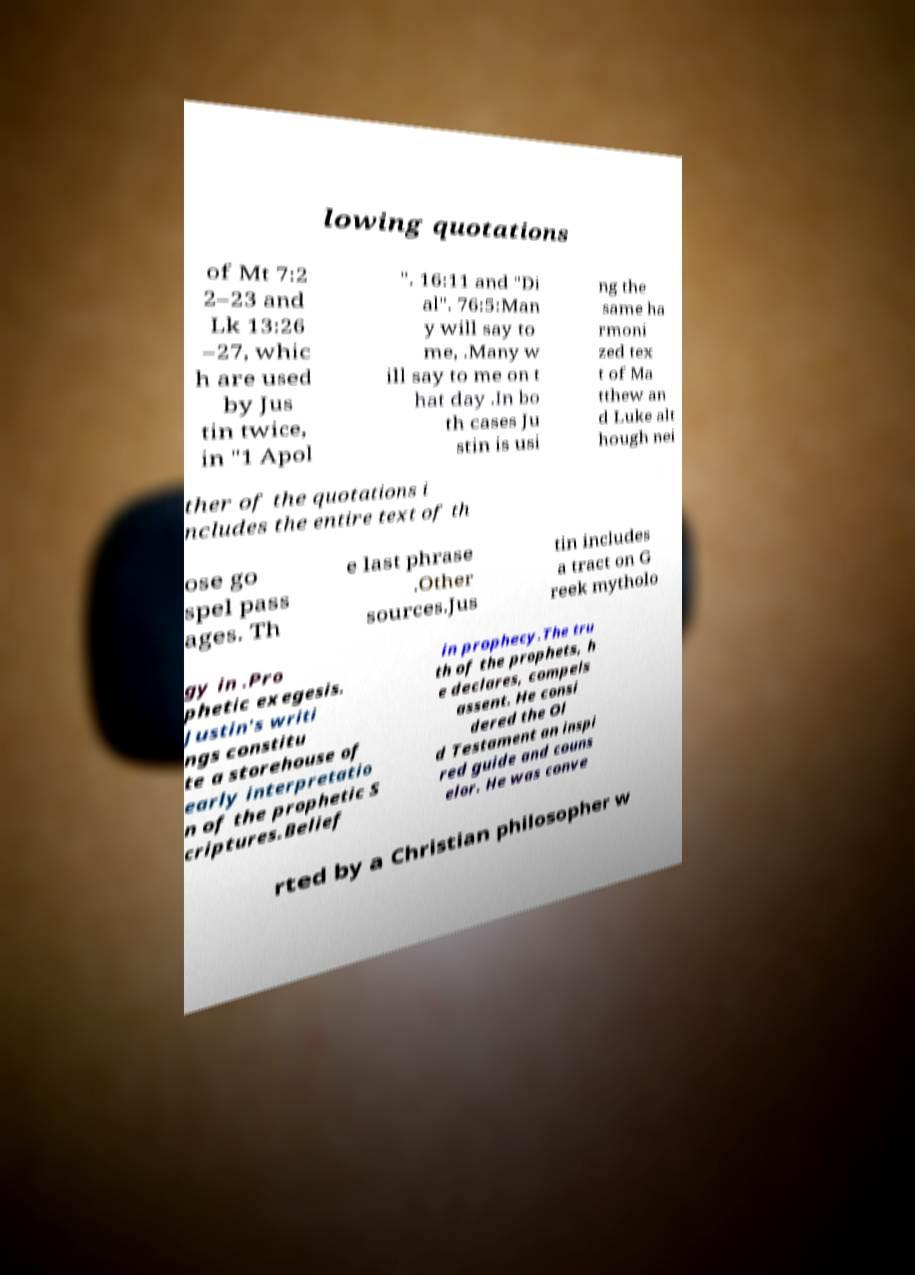Could you assist in decoding the text presented in this image and type it out clearly? lowing quotations of Mt 7:2 2–23 and Lk 13:26 –27, whic h are used by Jus tin twice, in "1 Apol ". 16:11 and "Di al". 76:5:Man y will say to me, .Many w ill say to me on t hat day .In bo th cases Ju stin is usi ng the same ha rmoni zed tex t of Ma tthew an d Luke alt hough nei ther of the quotations i ncludes the entire text of th ose go spel pass ages. Th e last phrase .Other sources.Jus tin includes a tract on G reek mytholo gy in .Pro phetic exegesis. Justin's writi ngs constitu te a storehouse of early interpretatio n of the prophetic S criptures.Belief in prophecy.The tru th of the prophets, h e declares, compels assent. He consi dered the Ol d Testament an inspi red guide and couns elor. He was conve rted by a Christian philosopher w 